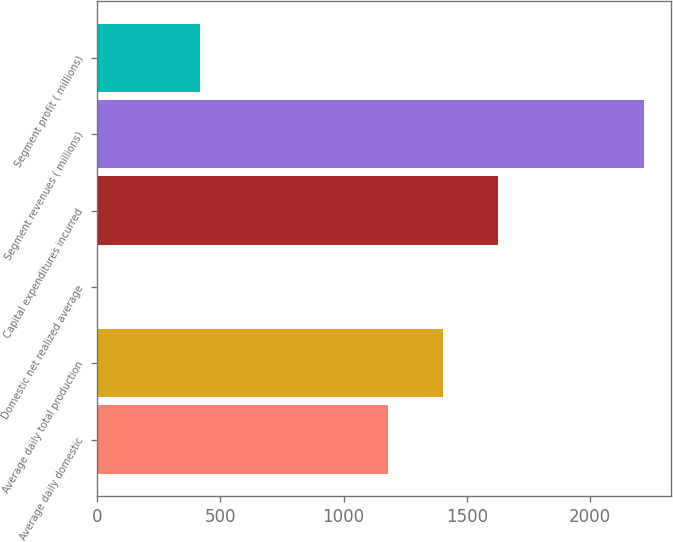<chart> <loc_0><loc_0><loc_500><loc_500><bar_chart><fcel>Average daily domestic<fcel>Average daily total production<fcel>Domestic net realized average<fcel>Capital expenditures incurred<fcel>Segment revenues ( millions)<fcel>Segment profit ( millions)<nl><fcel>1182<fcel>1403.48<fcel>4.22<fcel>1624.96<fcel>2219<fcel>418<nl></chart> 